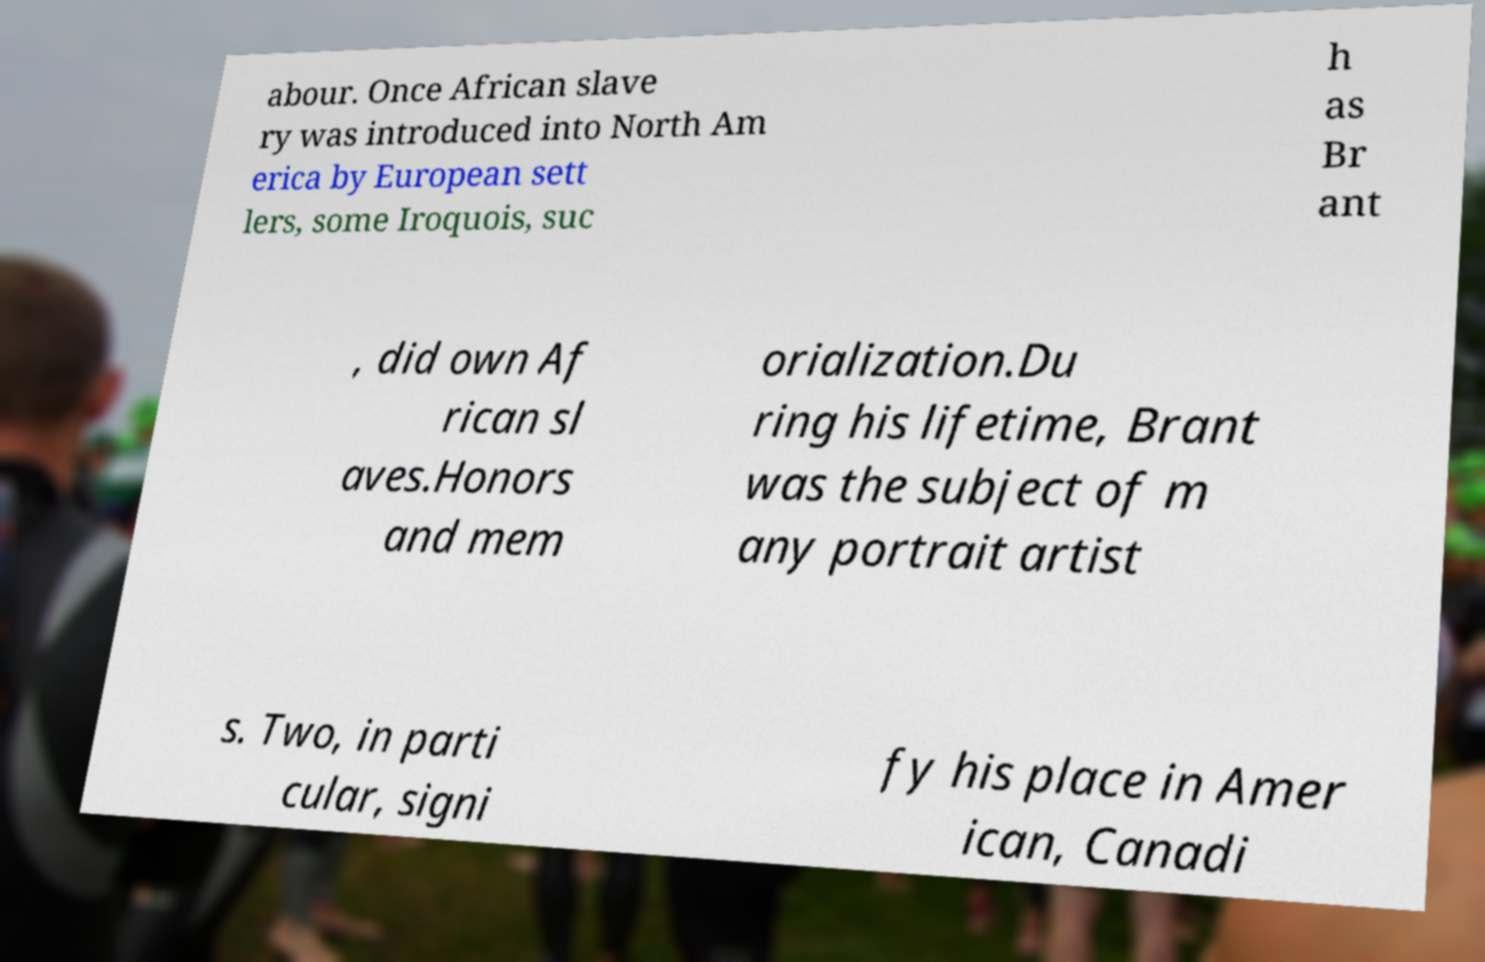Could you assist in decoding the text presented in this image and type it out clearly? abour. Once African slave ry was introduced into North Am erica by European sett lers, some Iroquois, suc h as Br ant , did own Af rican sl aves.Honors and mem orialization.Du ring his lifetime, Brant was the subject of m any portrait artist s. Two, in parti cular, signi fy his place in Amer ican, Canadi 